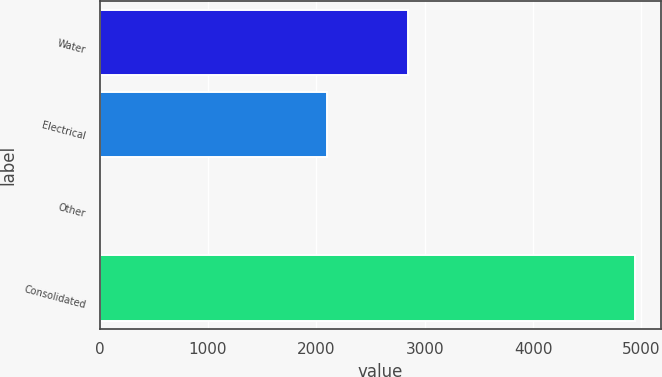Convert chart. <chart><loc_0><loc_0><loc_500><loc_500><bar_chart><fcel>Water<fcel>Electrical<fcel>Other<fcel>Consolidated<nl><fcel>2844.4<fcel>2097.9<fcel>5.8<fcel>4936.5<nl></chart> 